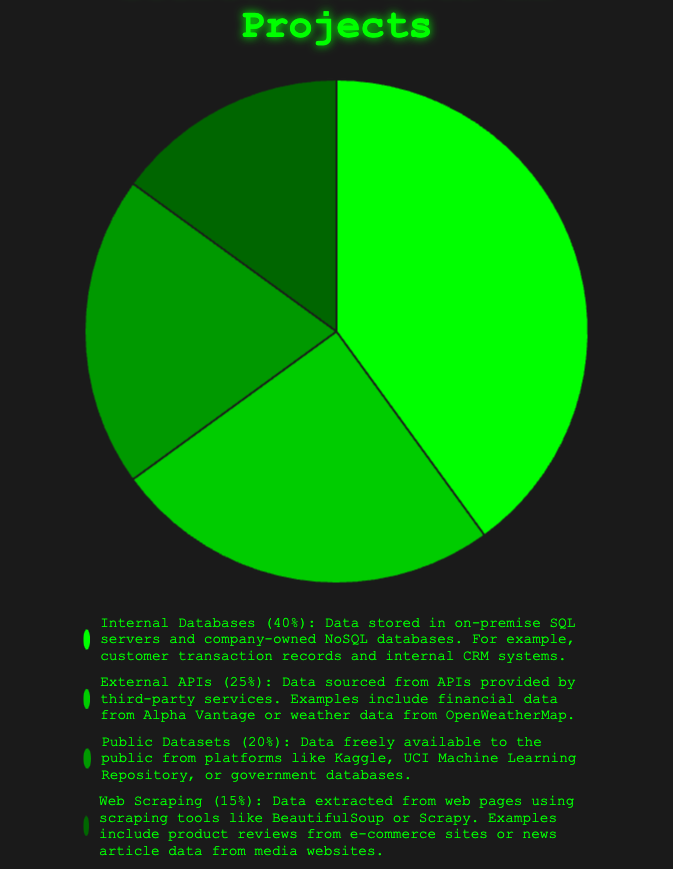What percentage of the data sources come from Internal Databases and External APIs combined? The figure shows that Internal Databases account for 40% and External APIs account for 25%. Adding these two percentages together gives 40% + 25% = 65%.
Answer: 65% Which data source has the smallest percentage share? According to the pie chart, the smallest percentage is for Web Scraping, which accounts for 15%.
Answer: Web Scraping What is the difference in percentage between Public Datasets and Web Scraping? The figure displays 20% for Public Datasets and 15% for Web Scraping. The difference between these two percentages is 20% - 15% = 5%.
Answer: 5% Which two sources have the closest percentage values, and what are their values? The two closest percentage values are for External APIs (25%) and Public Datasets (20%), with a difference of 5%.
Answer: External APIs and Public Datasets (25% and 20%) What is the total percentage of data sources not coming from Internal Databases? The figure shows that Internal Databases make up 40%. Therefore, the total percentage from other sources is 100% - 40% = 60%.
Answer: 60% How does the percentage of data sourced from External APIs compare to that from Web Scraping? The figure indicates that External APIs account for 25%, whereas Web Scraping accounts for 15%. External APIs have a higher percentage than Web Scraping by 10%.
Answer: External APIs have 10% more than Web Scraping Which source of data has the largest share, and what percentage does it represent? The pie chart shows that the largest share comes from Internal Databases, representing 40%.
Answer: Internal Databases (40%) If we add the percentages of Public Datasets and Web Scraping, is the result greater than the percentage of Internal Databases? Public Datasets contribute 20% and Web Scraping 15%. Adding these together gives 20% + 15% = 35%, which is less than the 40% from Internal Databases.
Answer: No What color represents the data source with the highest percentage, and what is that source? The data source with the highest percentage is Internal Databases at 40%, represented by green.
Answer: Green, Internal Databases 